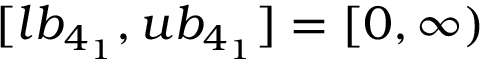<formula> <loc_0><loc_0><loc_500><loc_500>[ l b _ { 4 _ { 1 } } , u b _ { 4 _ { 1 } } ] = [ 0 , \infty )</formula> 